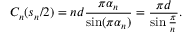Convert formula to latex. <formula><loc_0><loc_0><loc_500><loc_500>C _ { n } ( s _ { n } / 2 ) = n d \frac { \pi \alpha _ { n } } { \sin ( \pi \alpha _ { n } ) } = \frac { \pi d } { \sin \frac { \pi } { n } } .</formula> 